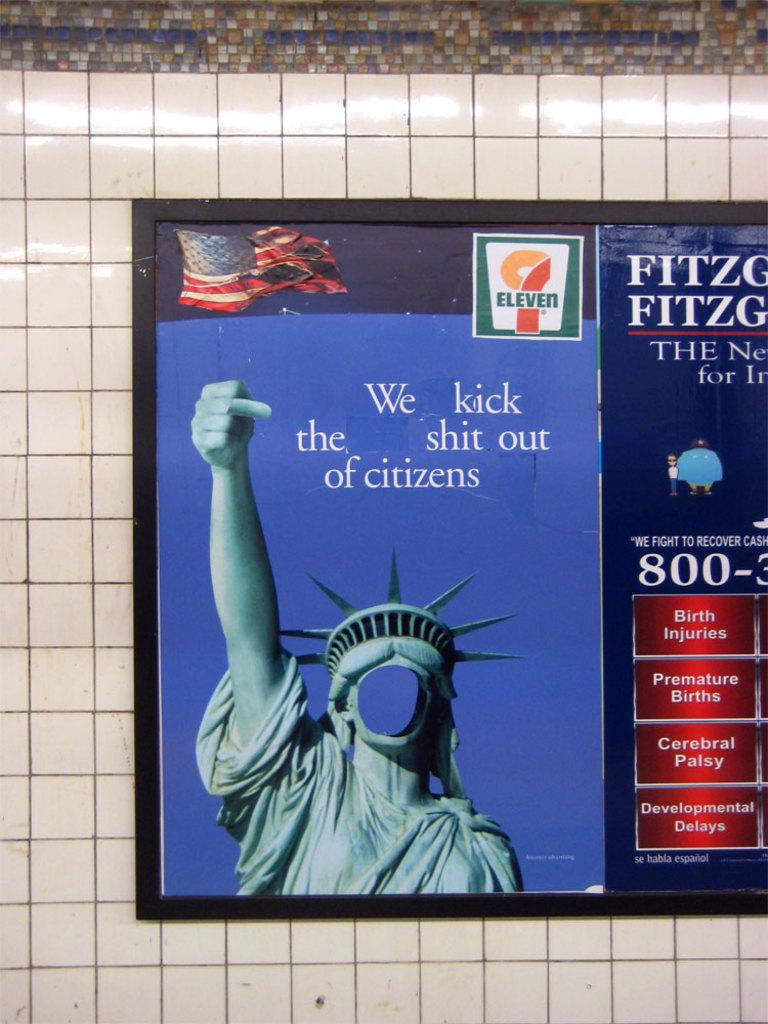<image>
Provide a brief description of the given image. An advertisement has been altered to say we kick the shit out of citizens. 